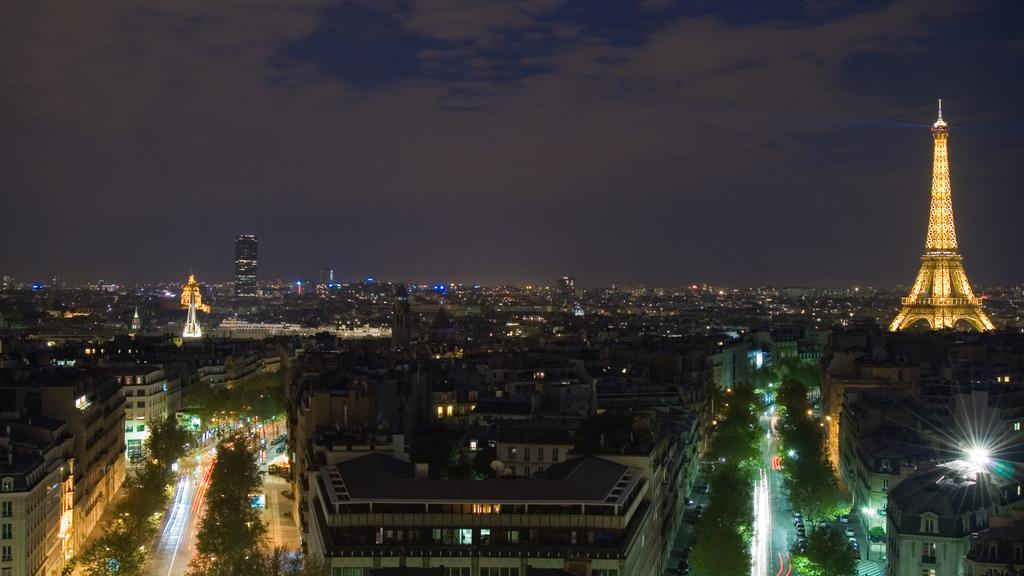What famous landmark can be seen in the image? The Eiffel Tower is visible in the image. What type of structures are present in the image besides the Eiffel Tower? There are buildings in the image. What can be seen illuminating the scene in the image? Lights are present in the image. What type of natural elements can be seen in the image? Trees are visible in the image. What other objects can be seen in the image? There are various objects in the image. What is visible in the background of the image? The sky is visible in the background of the image. What type of leather is used to make the houses in the image? There are no houses present in the image, and therefore no leather can be associated with them. 